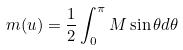Convert formula to latex. <formula><loc_0><loc_0><loc_500><loc_500>m ( u ) = \frac { 1 } { 2 } \int _ { 0 } ^ { \pi } { M \sin { \theta } d \theta }</formula> 